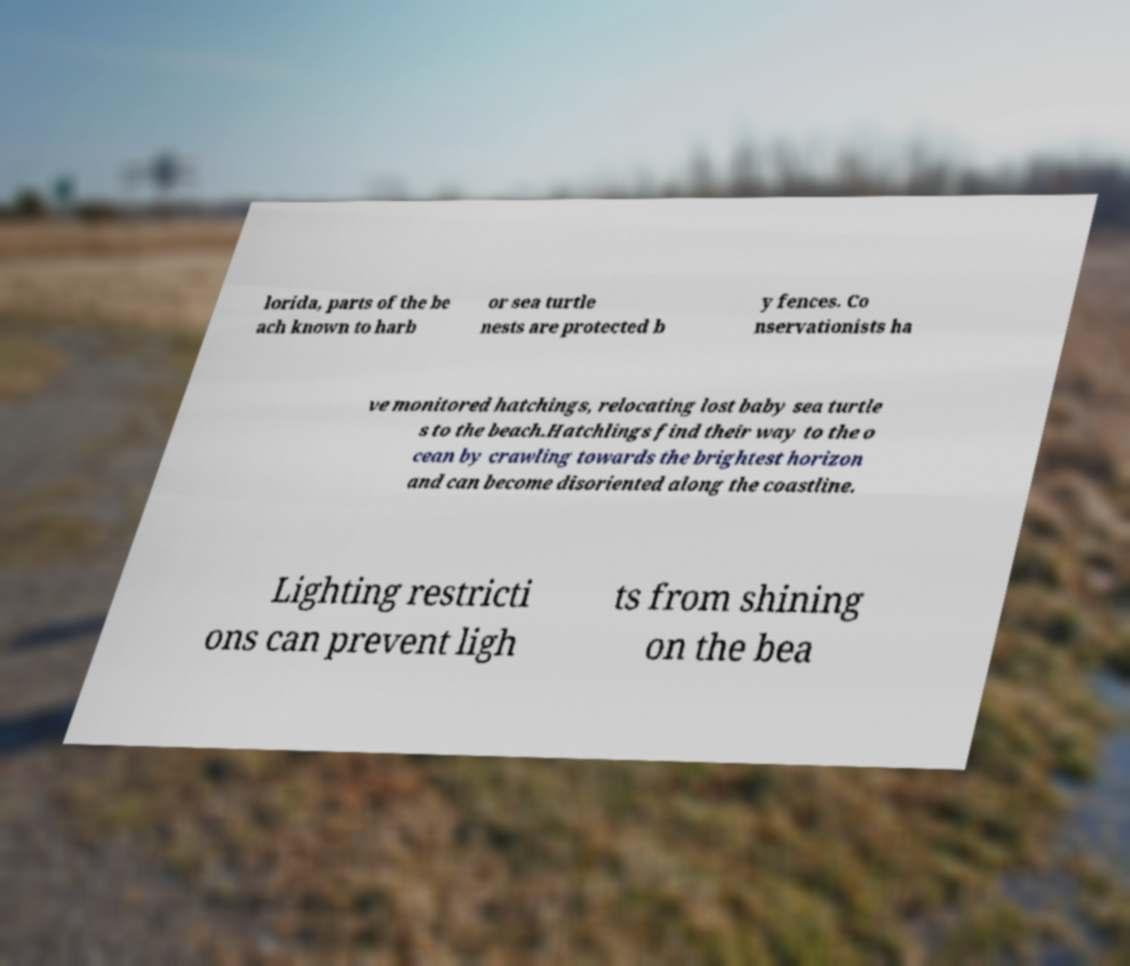Please read and relay the text visible in this image. What does it say? lorida, parts of the be ach known to harb or sea turtle nests are protected b y fences. Co nservationists ha ve monitored hatchings, relocating lost baby sea turtle s to the beach.Hatchlings find their way to the o cean by crawling towards the brightest horizon and can become disoriented along the coastline. Lighting restricti ons can prevent ligh ts from shining on the bea 